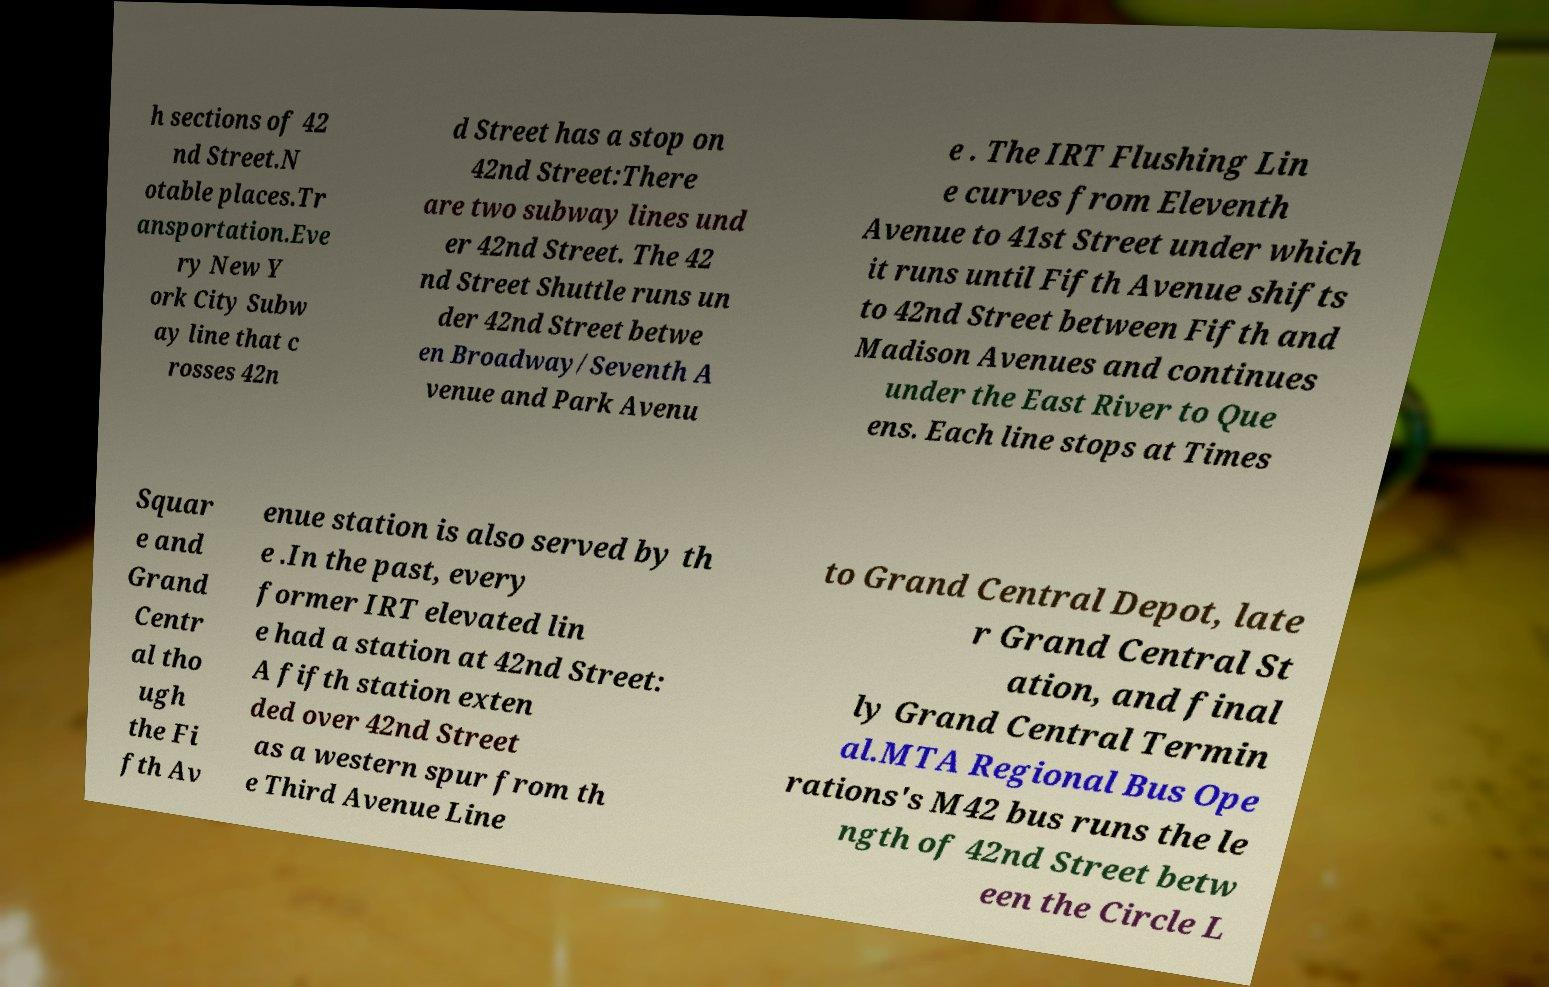Please read and relay the text visible in this image. What does it say? h sections of 42 nd Street.N otable places.Tr ansportation.Eve ry New Y ork City Subw ay line that c rosses 42n d Street has a stop on 42nd Street:There are two subway lines und er 42nd Street. The 42 nd Street Shuttle runs un der 42nd Street betwe en Broadway/Seventh A venue and Park Avenu e . The IRT Flushing Lin e curves from Eleventh Avenue to 41st Street under which it runs until Fifth Avenue shifts to 42nd Street between Fifth and Madison Avenues and continues under the East River to Que ens. Each line stops at Times Squar e and Grand Centr al tho ugh the Fi fth Av enue station is also served by th e .In the past, every former IRT elevated lin e had a station at 42nd Street: A fifth station exten ded over 42nd Street as a western spur from th e Third Avenue Line to Grand Central Depot, late r Grand Central St ation, and final ly Grand Central Termin al.MTA Regional Bus Ope rations's M42 bus runs the le ngth of 42nd Street betw een the Circle L 